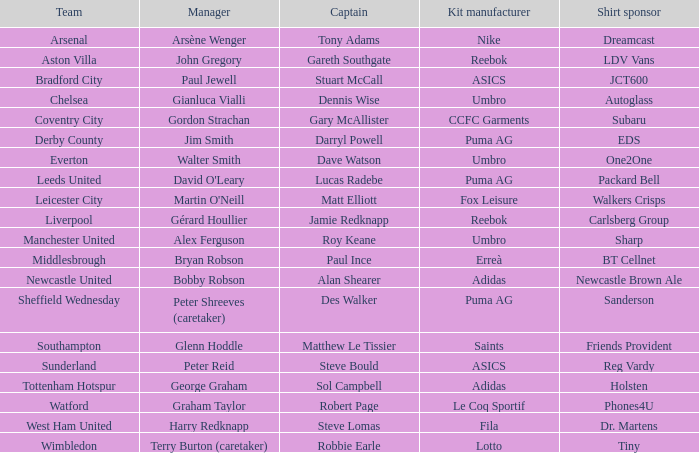Would you mind parsing the complete table? {'header': ['Team', 'Manager', 'Captain', 'Kit manufacturer', 'Shirt sponsor'], 'rows': [['Arsenal', 'Arsène Wenger', 'Tony Adams', 'Nike', 'Dreamcast'], ['Aston Villa', 'John Gregory', 'Gareth Southgate', 'Reebok', 'LDV Vans'], ['Bradford City', 'Paul Jewell', 'Stuart McCall', 'ASICS', 'JCT600'], ['Chelsea', 'Gianluca Vialli', 'Dennis Wise', 'Umbro', 'Autoglass'], ['Coventry City', 'Gordon Strachan', 'Gary McAllister', 'CCFC Garments', 'Subaru'], ['Derby County', 'Jim Smith', 'Darryl Powell', 'Puma AG', 'EDS'], ['Everton', 'Walter Smith', 'Dave Watson', 'Umbro', 'One2One'], ['Leeds United', "David O'Leary", 'Lucas Radebe', 'Puma AG', 'Packard Bell'], ['Leicester City', "Martin O'Neill", 'Matt Elliott', 'Fox Leisure', 'Walkers Crisps'], ['Liverpool', 'Gérard Houllier', 'Jamie Redknapp', 'Reebok', 'Carlsberg Group'], ['Manchester United', 'Alex Ferguson', 'Roy Keane', 'Umbro', 'Sharp'], ['Middlesbrough', 'Bryan Robson', 'Paul Ince', 'Erreà', 'BT Cellnet'], ['Newcastle United', 'Bobby Robson', 'Alan Shearer', 'Adidas', 'Newcastle Brown Ale'], ['Sheffield Wednesday', 'Peter Shreeves (caretaker)', 'Des Walker', 'Puma AG', 'Sanderson'], ['Southampton', 'Glenn Hoddle', 'Matthew Le Tissier', 'Saints', 'Friends Provident'], ['Sunderland', 'Peter Reid', 'Steve Bould', 'ASICS', 'Reg Vardy'], ['Tottenham Hotspur', 'George Graham', 'Sol Campbell', 'Adidas', 'Holsten'], ['Watford', 'Graham Taylor', 'Robert Page', 'Le Coq Sportif', 'Phones4U'], ['West Ham United', 'Harry Redknapp', 'Steve Lomas', 'Fila', 'Dr. Martens'], ['Wimbledon', 'Terry Burton (caretaker)', 'Robbie Earle', 'Lotto', 'Tiny']]} Which captain is under the management of gianluca vialli? Dennis Wise. 